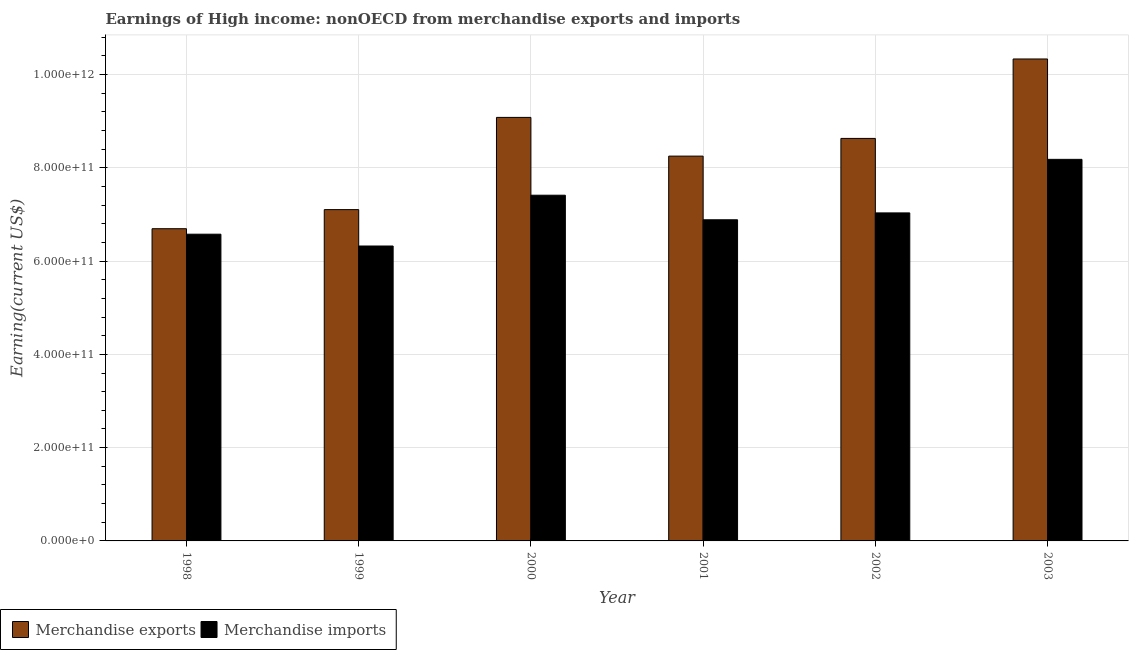How many different coloured bars are there?
Keep it short and to the point. 2. Are the number of bars per tick equal to the number of legend labels?
Your response must be concise. Yes. How many bars are there on the 5th tick from the left?
Offer a terse response. 2. What is the label of the 3rd group of bars from the left?
Your answer should be compact. 2000. What is the earnings from merchandise imports in 2000?
Offer a terse response. 7.41e+11. Across all years, what is the maximum earnings from merchandise imports?
Your answer should be very brief. 8.18e+11. Across all years, what is the minimum earnings from merchandise imports?
Your response must be concise. 6.32e+11. In which year was the earnings from merchandise exports maximum?
Keep it short and to the point. 2003. What is the total earnings from merchandise imports in the graph?
Offer a very short reply. 4.24e+12. What is the difference between the earnings from merchandise imports in 2001 and that in 2003?
Offer a very short reply. -1.30e+11. What is the difference between the earnings from merchandise exports in 1998 and the earnings from merchandise imports in 2002?
Ensure brevity in your answer.  -1.94e+11. What is the average earnings from merchandise imports per year?
Provide a succinct answer. 7.07e+11. What is the ratio of the earnings from merchandise exports in 2002 to that in 2003?
Make the answer very short. 0.84. Is the difference between the earnings from merchandise imports in 1999 and 2003 greater than the difference between the earnings from merchandise exports in 1999 and 2003?
Offer a terse response. No. What is the difference between the highest and the second highest earnings from merchandise imports?
Keep it short and to the point. 7.69e+1. What is the difference between the highest and the lowest earnings from merchandise exports?
Keep it short and to the point. 3.64e+11. In how many years, is the earnings from merchandise imports greater than the average earnings from merchandise imports taken over all years?
Offer a very short reply. 2. How many bars are there?
Your answer should be very brief. 12. Are all the bars in the graph horizontal?
Your response must be concise. No. What is the difference between two consecutive major ticks on the Y-axis?
Offer a terse response. 2.00e+11. Are the values on the major ticks of Y-axis written in scientific E-notation?
Offer a very short reply. Yes. Does the graph contain any zero values?
Provide a succinct answer. No. Does the graph contain grids?
Provide a short and direct response. Yes. What is the title of the graph?
Offer a terse response. Earnings of High income: nonOECD from merchandise exports and imports. What is the label or title of the X-axis?
Your answer should be compact. Year. What is the label or title of the Y-axis?
Ensure brevity in your answer.  Earning(current US$). What is the Earning(current US$) in Merchandise exports in 1998?
Provide a short and direct response. 6.69e+11. What is the Earning(current US$) of Merchandise imports in 1998?
Your answer should be very brief. 6.58e+11. What is the Earning(current US$) in Merchandise exports in 1999?
Provide a short and direct response. 7.10e+11. What is the Earning(current US$) in Merchandise imports in 1999?
Provide a short and direct response. 6.32e+11. What is the Earning(current US$) of Merchandise exports in 2000?
Offer a terse response. 9.08e+11. What is the Earning(current US$) in Merchandise imports in 2000?
Provide a succinct answer. 7.41e+11. What is the Earning(current US$) of Merchandise exports in 2001?
Provide a short and direct response. 8.25e+11. What is the Earning(current US$) of Merchandise imports in 2001?
Make the answer very short. 6.89e+11. What is the Earning(current US$) in Merchandise exports in 2002?
Make the answer very short. 8.63e+11. What is the Earning(current US$) in Merchandise imports in 2002?
Ensure brevity in your answer.  7.03e+11. What is the Earning(current US$) in Merchandise exports in 2003?
Give a very brief answer. 1.03e+12. What is the Earning(current US$) in Merchandise imports in 2003?
Ensure brevity in your answer.  8.18e+11. Across all years, what is the maximum Earning(current US$) in Merchandise exports?
Your answer should be very brief. 1.03e+12. Across all years, what is the maximum Earning(current US$) in Merchandise imports?
Ensure brevity in your answer.  8.18e+11. Across all years, what is the minimum Earning(current US$) in Merchandise exports?
Your response must be concise. 6.69e+11. Across all years, what is the minimum Earning(current US$) in Merchandise imports?
Your answer should be compact. 6.32e+11. What is the total Earning(current US$) of Merchandise exports in the graph?
Offer a terse response. 5.01e+12. What is the total Earning(current US$) in Merchandise imports in the graph?
Offer a terse response. 4.24e+12. What is the difference between the Earning(current US$) of Merchandise exports in 1998 and that in 1999?
Give a very brief answer. -4.09e+1. What is the difference between the Earning(current US$) of Merchandise imports in 1998 and that in 1999?
Ensure brevity in your answer.  2.53e+1. What is the difference between the Earning(current US$) of Merchandise exports in 1998 and that in 2000?
Provide a short and direct response. -2.39e+11. What is the difference between the Earning(current US$) of Merchandise imports in 1998 and that in 2000?
Provide a succinct answer. -8.36e+1. What is the difference between the Earning(current US$) of Merchandise exports in 1998 and that in 2001?
Provide a succinct answer. -1.56e+11. What is the difference between the Earning(current US$) of Merchandise imports in 1998 and that in 2001?
Ensure brevity in your answer.  -3.09e+1. What is the difference between the Earning(current US$) in Merchandise exports in 1998 and that in 2002?
Your response must be concise. -1.94e+11. What is the difference between the Earning(current US$) of Merchandise imports in 1998 and that in 2002?
Your answer should be very brief. -4.56e+1. What is the difference between the Earning(current US$) in Merchandise exports in 1998 and that in 2003?
Provide a succinct answer. -3.64e+11. What is the difference between the Earning(current US$) in Merchandise imports in 1998 and that in 2003?
Provide a short and direct response. -1.60e+11. What is the difference between the Earning(current US$) in Merchandise exports in 1999 and that in 2000?
Your answer should be compact. -1.98e+11. What is the difference between the Earning(current US$) in Merchandise imports in 1999 and that in 2000?
Ensure brevity in your answer.  -1.09e+11. What is the difference between the Earning(current US$) in Merchandise exports in 1999 and that in 2001?
Your response must be concise. -1.15e+11. What is the difference between the Earning(current US$) of Merchandise imports in 1999 and that in 2001?
Make the answer very short. -5.63e+1. What is the difference between the Earning(current US$) of Merchandise exports in 1999 and that in 2002?
Your answer should be very brief. -1.53e+11. What is the difference between the Earning(current US$) in Merchandise imports in 1999 and that in 2002?
Offer a very short reply. -7.10e+1. What is the difference between the Earning(current US$) of Merchandise exports in 1999 and that in 2003?
Ensure brevity in your answer.  -3.23e+11. What is the difference between the Earning(current US$) in Merchandise imports in 1999 and that in 2003?
Provide a short and direct response. -1.86e+11. What is the difference between the Earning(current US$) in Merchandise exports in 2000 and that in 2001?
Provide a succinct answer. 8.30e+1. What is the difference between the Earning(current US$) in Merchandise imports in 2000 and that in 2001?
Your response must be concise. 5.26e+1. What is the difference between the Earning(current US$) in Merchandise exports in 2000 and that in 2002?
Your answer should be compact. 4.51e+1. What is the difference between the Earning(current US$) of Merchandise imports in 2000 and that in 2002?
Provide a short and direct response. 3.79e+1. What is the difference between the Earning(current US$) in Merchandise exports in 2000 and that in 2003?
Your answer should be compact. -1.25e+11. What is the difference between the Earning(current US$) of Merchandise imports in 2000 and that in 2003?
Keep it short and to the point. -7.69e+1. What is the difference between the Earning(current US$) in Merchandise exports in 2001 and that in 2002?
Your response must be concise. -3.80e+1. What is the difference between the Earning(current US$) of Merchandise imports in 2001 and that in 2002?
Ensure brevity in your answer.  -1.47e+1. What is the difference between the Earning(current US$) of Merchandise exports in 2001 and that in 2003?
Ensure brevity in your answer.  -2.08e+11. What is the difference between the Earning(current US$) in Merchandise imports in 2001 and that in 2003?
Give a very brief answer. -1.30e+11. What is the difference between the Earning(current US$) in Merchandise exports in 2002 and that in 2003?
Keep it short and to the point. -1.70e+11. What is the difference between the Earning(current US$) in Merchandise imports in 2002 and that in 2003?
Make the answer very short. -1.15e+11. What is the difference between the Earning(current US$) in Merchandise exports in 1998 and the Earning(current US$) in Merchandise imports in 1999?
Keep it short and to the point. 3.71e+1. What is the difference between the Earning(current US$) in Merchandise exports in 1998 and the Earning(current US$) in Merchandise imports in 2000?
Your answer should be very brief. -7.18e+1. What is the difference between the Earning(current US$) in Merchandise exports in 1998 and the Earning(current US$) in Merchandise imports in 2001?
Make the answer very short. -1.92e+1. What is the difference between the Earning(current US$) of Merchandise exports in 1998 and the Earning(current US$) of Merchandise imports in 2002?
Offer a terse response. -3.39e+1. What is the difference between the Earning(current US$) in Merchandise exports in 1998 and the Earning(current US$) in Merchandise imports in 2003?
Offer a terse response. -1.49e+11. What is the difference between the Earning(current US$) in Merchandise exports in 1999 and the Earning(current US$) in Merchandise imports in 2000?
Your answer should be very brief. -3.09e+1. What is the difference between the Earning(current US$) in Merchandise exports in 1999 and the Earning(current US$) in Merchandise imports in 2001?
Give a very brief answer. 2.18e+1. What is the difference between the Earning(current US$) in Merchandise exports in 1999 and the Earning(current US$) in Merchandise imports in 2002?
Your answer should be very brief. 7.04e+09. What is the difference between the Earning(current US$) of Merchandise exports in 1999 and the Earning(current US$) of Merchandise imports in 2003?
Offer a very short reply. -1.08e+11. What is the difference between the Earning(current US$) of Merchandise exports in 2000 and the Earning(current US$) of Merchandise imports in 2001?
Keep it short and to the point. 2.19e+11. What is the difference between the Earning(current US$) in Merchandise exports in 2000 and the Earning(current US$) in Merchandise imports in 2002?
Your response must be concise. 2.05e+11. What is the difference between the Earning(current US$) in Merchandise exports in 2000 and the Earning(current US$) in Merchandise imports in 2003?
Your answer should be very brief. 9.00e+1. What is the difference between the Earning(current US$) in Merchandise exports in 2001 and the Earning(current US$) in Merchandise imports in 2002?
Your answer should be very brief. 1.22e+11. What is the difference between the Earning(current US$) in Merchandise exports in 2001 and the Earning(current US$) in Merchandise imports in 2003?
Ensure brevity in your answer.  6.92e+09. What is the difference between the Earning(current US$) of Merchandise exports in 2002 and the Earning(current US$) of Merchandise imports in 2003?
Offer a very short reply. 4.49e+1. What is the average Earning(current US$) of Merchandise exports per year?
Provide a succinct answer. 8.35e+11. What is the average Earning(current US$) in Merchandise imports per year?
Offer a terse response. 7.07e+11. In the year 1998, what is the difference between the Earning(current US$) in Merchandise exports and Earning(current US$) in Merchandise imports?
Provide a short and direct response. 1.18e+1. In the year 1999, what is the difference between the Earning(current US$) in Merchandise exports and Earning(current US$) in Merchandise imports?
Provide a short and direct response. 7.80e+1. In the year 2000, what is the difference between the Earning(current US$) of Merchandise exports and Earning(current US$) of Merchandise imports?
Provide a succinct answer. 1.67e+11. In the year 2001, what is the difference between the Earning(current US$) in Merchandise exports and Earning(current US$) in Merchandise imports?
Provide a succinct answer. 1.36e+11. In the year 2002, what is the difference between the Earning(current US$) in Merchandise exports and Earning(current US$) in Merchandise imports?
Your answer should be very brief. 1.60e+11. In the year 2003, what is the difference between the Earning(current US$) of Merchandise exports and Earning(current US$) of Merchandise imports?
Provide a short and direct response. 2.15e+11. What is the ratio of the Earning(current US$) in Merchandise exports in 1998 to that in 1999?
Keep it short and to the point. 0.94. What is the ratio of the Earning(current US$) of Merchandise imports in 1998 to that in 1999?
Ensure brevity in your answer.  1.04. What is the ratio of the Earning(current US$) in Merchandise exports in 1998 to that in 2000?
Offer a terse response. 0.74. What is the ratio of the Earning(current US$) of Merchandise imports in 1998 to that in 2000?
Offer a terse response. 0.89. What is the ratio of the Earning(current US$) of Merchandise exports in 1998 to that in 2001?
Keep it short and to the point. 0.81. What is the ratio of the Earning(current US$) of Merchandise imports in 1998 to that in 2001?
Offer a very short reply. 0.96. What is the ratio of the Earning(current US$) of Merchandise exports in 1998 to that in 2002?
Provide a short and direct response. 0.78. What is the ratio of the Earning(current US$) of Merchandise imports in 1998 to that in 2002?
Provide a short and direct response. 0.94. What is the ratio of the Earning(current US$) of Merchandise exports in 1998 to that in 2003?
Keep it short and to the point. 0.65. What is the ratio of the Earning(current US$) of Merchandise imports in 1998 to that in 2003?
Make the answer very short. 0.8. What is the ratio of the Earning(current US$) in Merchandise exports in 1999 to that in 2000?
Your answer should be very brief. 0.78. What is the ratio of the Earning(current US$) of Merchandise imports in 1999 to that in 2000?
Provide a succinct answer. 0.85. What is the ratio of the Earning(current US$) in Merchandise exports in 1999 to that in 2001?
Provide a succinct answer. 0.86. What is the ratio of the Earning(current US$) of Merchandise imports in 1999 to that in 2001?
Ensure brevity in your answer.  0.92. What is the ratio of the Earning(current US$) in Merchandise exports in 1999 to that in 2002?
Your answer should be very brief. 0.82. What is the ratio of the Earning(current US$) in Merchandise imports in 1999 to that in 2002?
Keep it short and to the point. 0.9. What is the ratio of the Earning(current US$) of Merchandise exports in 1999 to that in 2003?
Ensure brevity in your answer.  0.69. What is the ratio of the Earning(current US$) of Merchandise imports in 1999 to that in 2003?
Keep it short and to the point. 0.77. What is the ratio of the Earning(current US$) of Merchandise exports in 2000 to that in 2001?
Your answer should be compact. 1.1. What is the ratio of the Earning(current US$) in Merchandise imports in 2000 to that in 2001?
Offer a terse response. 1.08. What is the ratio of the Earning(current US$) of Merchandise exports in 2000 to that in 2002?
Your response must be concise. 1.05. What is the ratio of the Earning(current US$) in Merchandise imports in 2000 to that in 2002?
Keep it short and to the point. 1.05. What is the ratio of the Earning(current US$) of Merchandise exports in 2000 to that in 2003?
Provide a short and direct response. 0.88. What is the ratio of the Earning(current US$) of Merchandise imports in 2000 to that in 2003?
Your response must be concise. 0.91. What is the ratio of the Earning(current US$) of Merchandise exports in 2001 to that in 2002?
Offer a very short reply. 0.96. What is the ratio of the Earning(current US$) in Merchandise imports in 2001 to that in 2002?
Offer a terse response. 0.98. What is the ratio of the Earning(current US$) of Merchandise exports in 2001 to that in 2003?
Give a very brief answer. 0.8. What is the ratio of the Earning(current US$) of Merchandise imports in 2001 to that in 2003?
Give a very brief answer. 0.84. What is the ratio of the Earning(current US$) of Merchandise exports in 2002 to that in 2003?
Give a very brief answer. 0.84. What is the ratio of the Earning(current US$) of Merchandise imports in 2002 to that in 2003?
Offer a terse response. 0.86. What is the difference between the highest and the second highest Earning(current US$) of Merchandise exports?
Offer a very short reply. 1.25e+11. What is the difference between the highest and the second highest Earning(current US$) of Merchandise imports?
Offer a terse response. 7.69e+1. What is the difference between the highest and the lowest Earning(current US$) in Merchandise exports?
Provide a succinct answer. 3.64e+11. What is the difference between the highest and the lowest Earning(current US$) of Merchandise imports?
Give a very brief answer. 1.86e+11. 